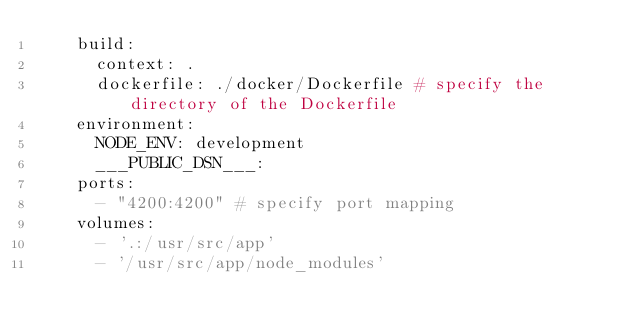Convert code to text. <code><loc_0><loc_0><loc_500><loc_500><_YAML_>    build:
      context: .
      dockerfile: ./docker/Dockerfile # specify the directory of the Dockerfile
    environment:
      NODE_ENV: development
      ___PUBLIC_DSN___:
    ports:
      - "4200:4200" # specify port mapping
    volumes:
      - '.:/usr/src/app'
      - '/usr/src/app/node_modules'
</code> 